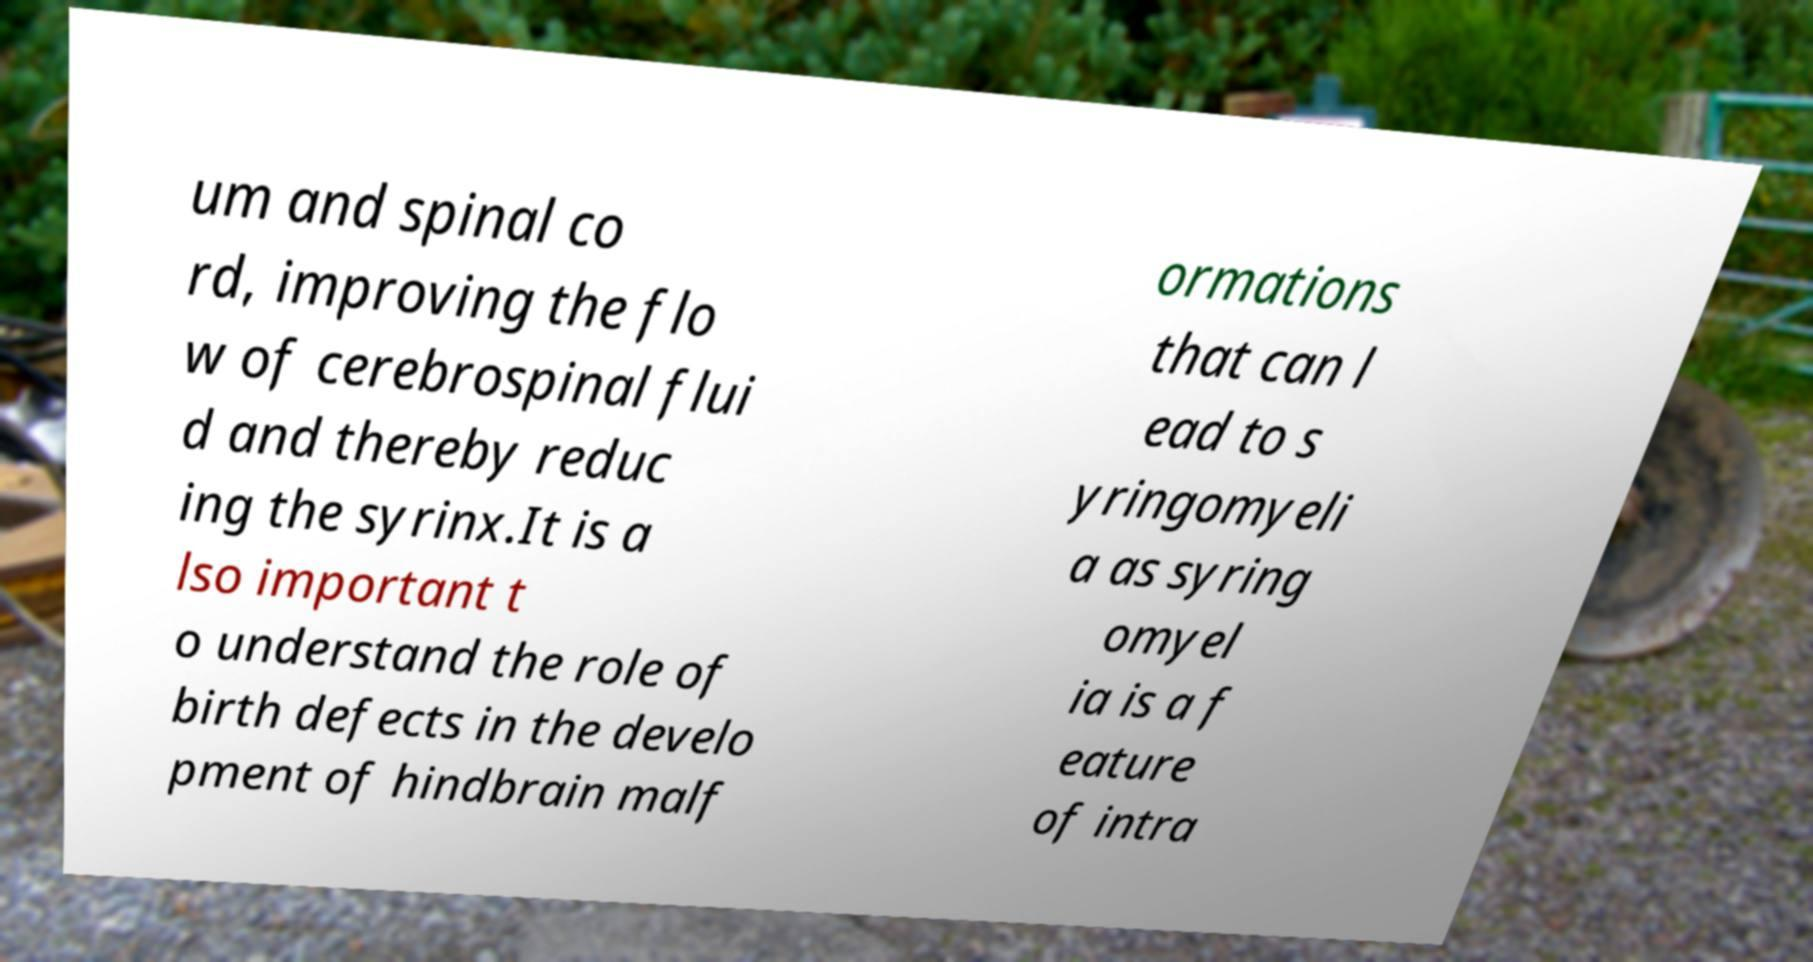Please read and relay the text visible in this image. What does it say? um and spinal co rd, improving the flo w of cerebrospinal flui d and thereby reduc ing the syrinx.It is a lso important t o understand the role of birth defects in the develo pment of hindbrain malf ormations that can l ead to s yringomyeli a as syring omyel ia is a f eature of intra 